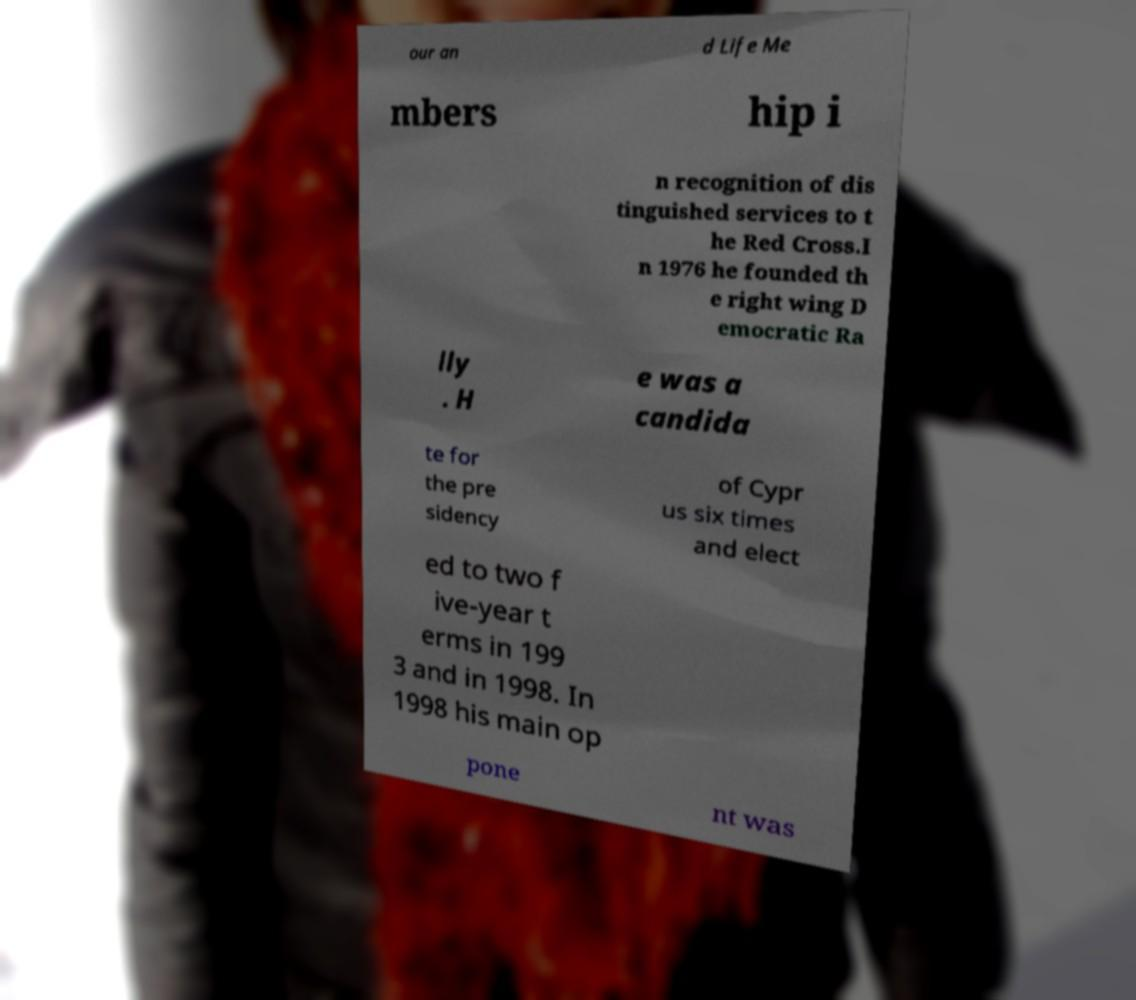Please identify and transcribe the text found in this image. our an d Life Me mbers hip i n recognition of dis tinguished services to t he Red Cross.I n 1976 he founded th e right wing D emocratic Ra lly . H e was a candida te for the pre sidency of Cypr us six times and elect ed to two f ive-year t erms in 199 3 and in 1998. In 1998 his main op pone nt was 